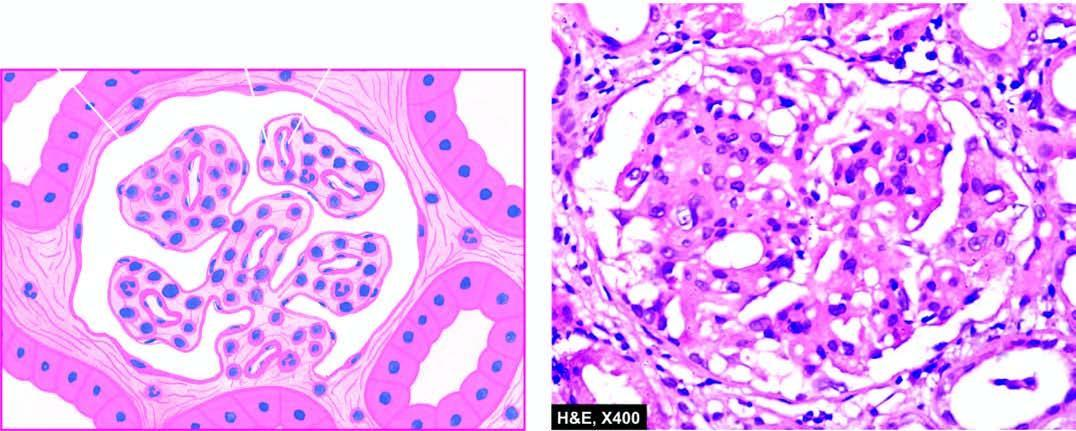do salt bridges show lobulation and mesangial hypercellularity?
Answer the question using a single word or phrase. No 